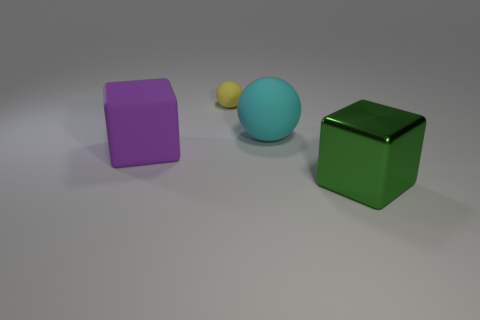What is the size of the cube right of the big cube to the left of the big block that is to the right of the large purple rubber block?
Provide a succinct answer. Large. Is there a small ball that is in front of the matte thing in front of the sphere in front of the small yellow object?
Keep it short and to the point. No. Is the number of green metal things greater than the number of large cyan metallic objects?
Provide a short and direct response. Yes. The thing that is in front of the purple thing is what color?
Your answer should be very brief. Green. Are there more big metallic blocks that are behind the small yellow matte object than large rubber blocks?
Ensure brevity in your answer.  No. Is the big green cube made of the same material as the yellow sphere?
Your answer should be very brief. No. How many other objects are the same shape as the small matte object?
Your answer should be compact. 1. Is there any other thing that is the same material as the large cyan thing?
Offer a very short reply. Yes. The ball behind the big matte thing that is on the right side of the big cube that is to the left of the tiny matte sphere is what color?
Provide a succinct answer. Yellow. Does the matte thing right of the tiny rubber sphere have the same shape as the small yellow matte thing?
Give a very brief answer. Yes. 